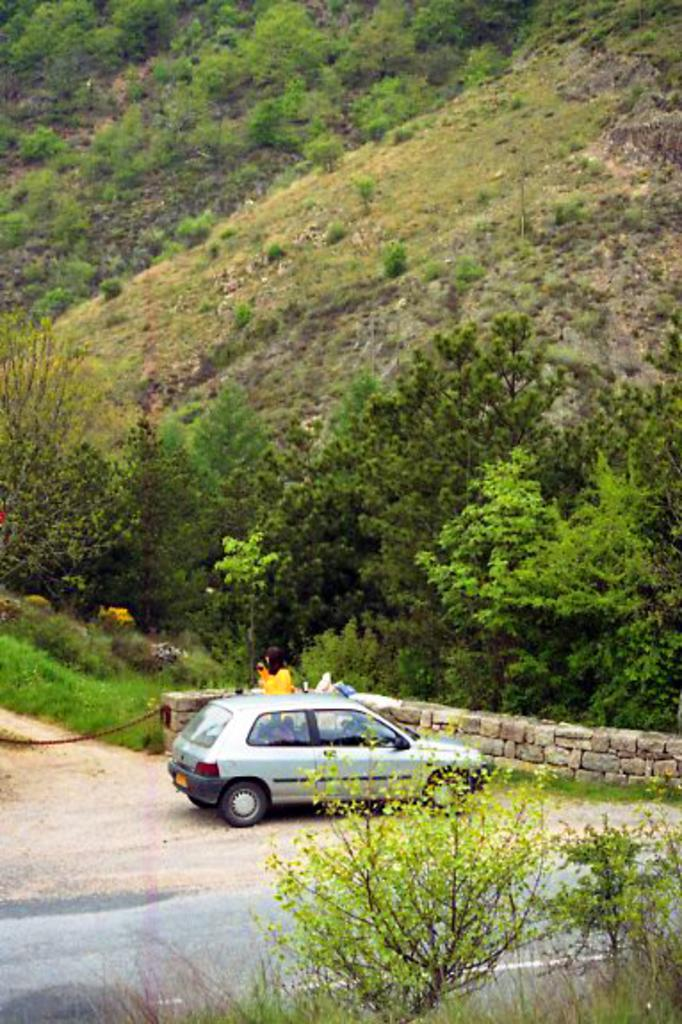What is the main subject of the image? The main subject of the image is a car on the road. Are there any people in the image? Yes, there are two people beside the car. What can be seen in the background of the image? There is a hill visible in the image, along with grass and trees. What type of tomatoes are growing on the hill in the image? There are no tomatoes visible in the image; the hill is covered with grass and trees. 